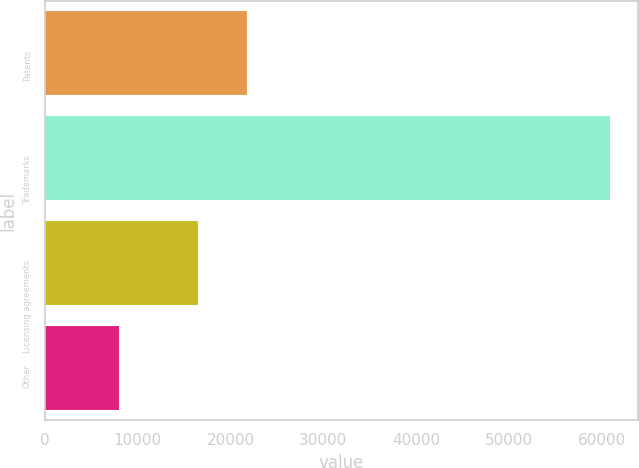<chart> <loc_0><loc_0><loc_500><loc_500><bar_chart><fcel>Patents<fcel>Trademarks<fcel>Licensing agreements<fcel>Other<nl><fcel>21740.4<fcel>60838<fcel>16458<fcel>8014<nl></chart> 